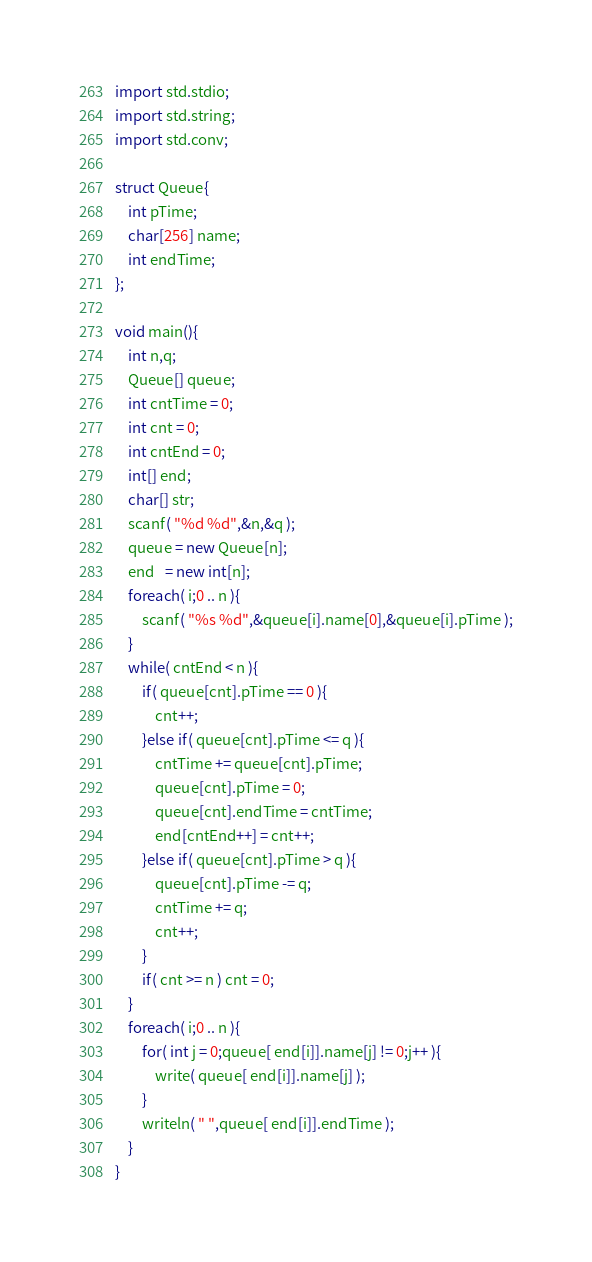<code> <loc_0><loc_0><loc_500><loc_500><_D_>import std.stdio;
import std.string;
import std.conv;

struct Queue{
	int pTime;
	char[256] name;
	int endTime;
};

void main(){
	int n,q;
	Queue[] queue;
	int cntTime = 0;
	int cnt = 0;
	int cntEnd = 0;
	int[] end;
	char[] str;
	scanf( "%d %d",&n,&q );
	queue = new Queue[n];
	end   = new int[n];
	foreach( i;0 .. n ){
		scanf( "%s %d",&queue[i].name[0],&queue[i].pTime );
	}
	while( cntEnd < n ){
		if( queue[cnt].pTime == 0 ){
			cnt++;
		}else if( queue[cnt].pTime <= q ){
			cntTime += queue[cnt].pTime;
			queue[cnt].pTime = 0;
			queue[cnt].endTime = cntTime;
			end[cntEnd++] = cnt++;
		}else if( queue[cnt].pTime > q ){
			queue[cnt].pTime -= q;
			cntTime += q;
			cnt++;
		}
		if( cnt >= n ) cnt = 0;
	}
	foreach( i;0 .. n ){
		for( int j = 0;queue[ end[i]].name[j] != 0;j++ ){
			write( queue[ end[i]].name[j] );
		}
		writeln( " ",queue[ end[i]].endTime );
	}
}</code> 